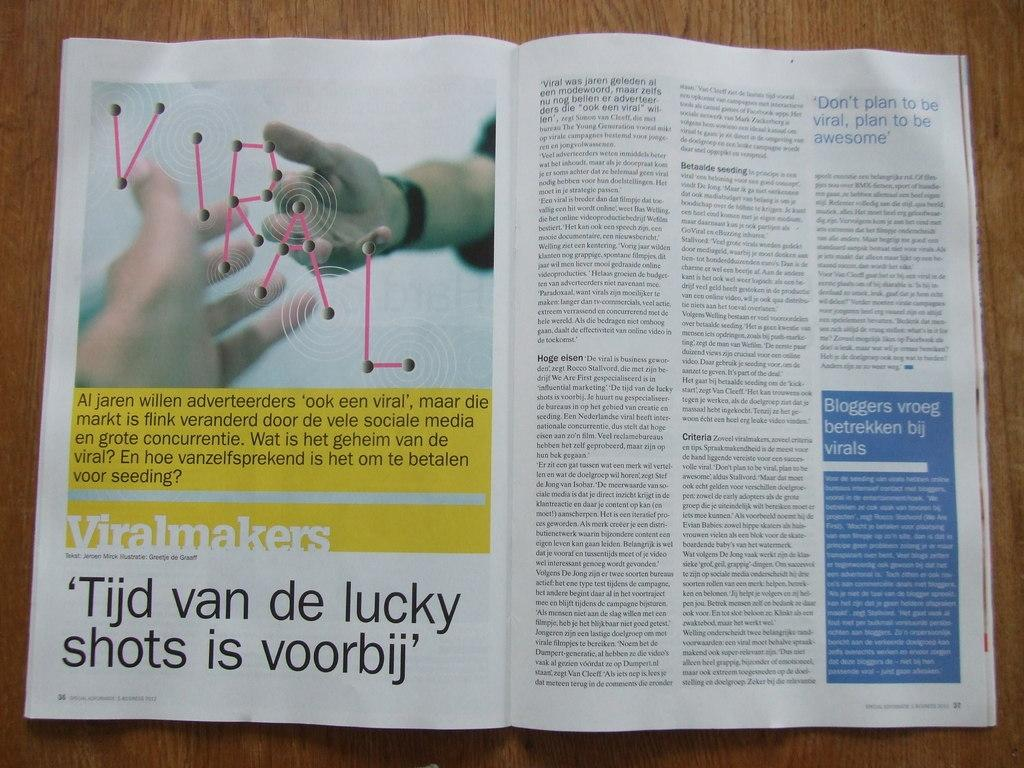<image>
Give a short and clear explanation of the subsequent image. The pages on display are number 36 and 37. 